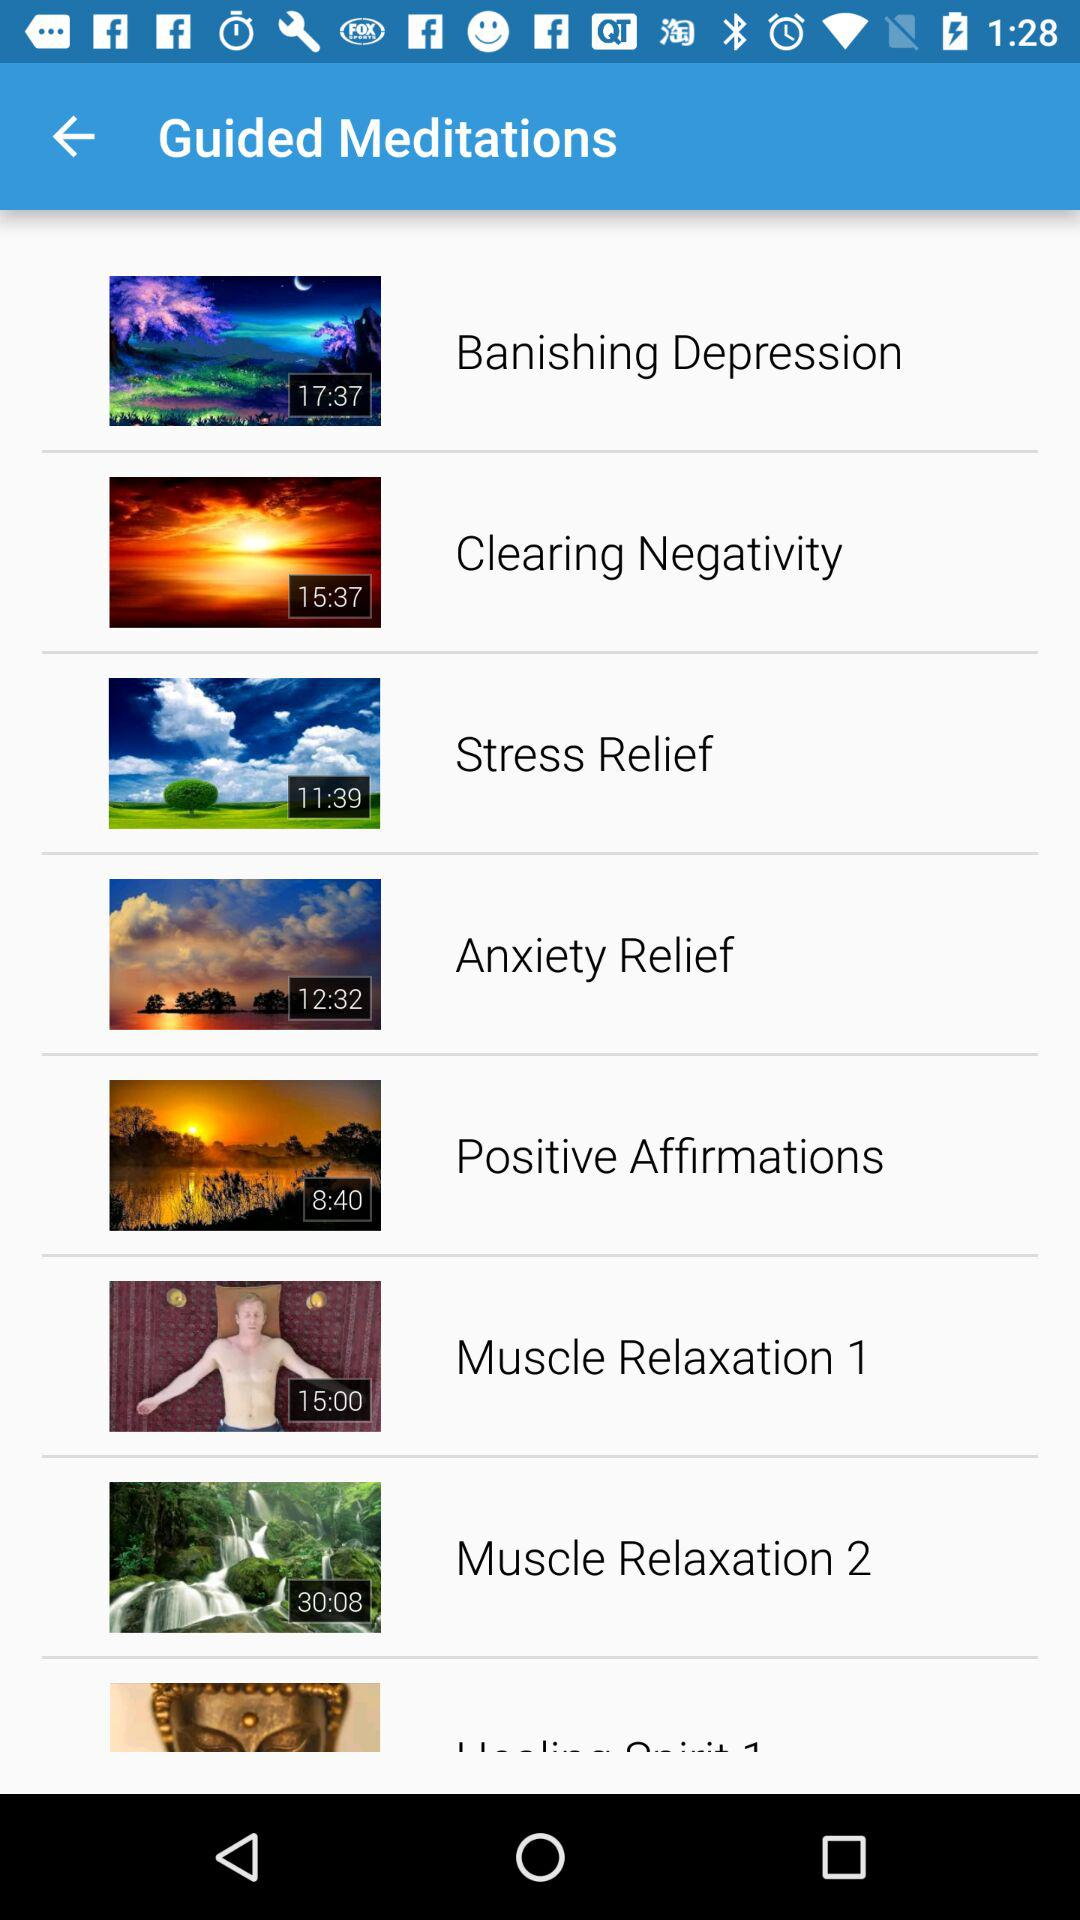How long is the time duration of the muscle relaxation1? The time duration is 15 minutes. 